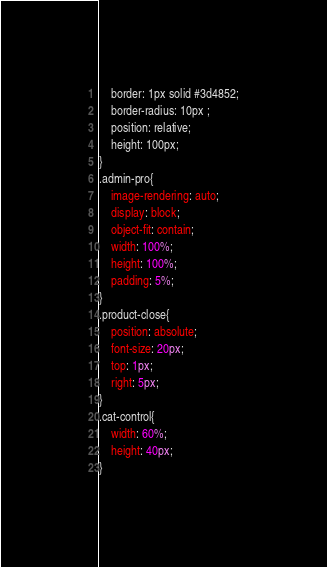Convert code to text. <code><loc_0><loc_0><loc_500><loc_500><_CSS_>    border: 1px solid #3d4852;
    border-radius: 10px ;
    position: relative;
    height: 100px;
}
.admin-pro{
    image-rendering: auto;
    display: block;
    object-fit: contain;
    width: 100%;
    height: 100%;
    padding: 5%;
}
.product-close{
    position: absolute;
    font-size: 20px;
    top: 1px;
    right: 5px;
}
.cat-control{
    width: 60%;
    height: 40px;
}

</code> 